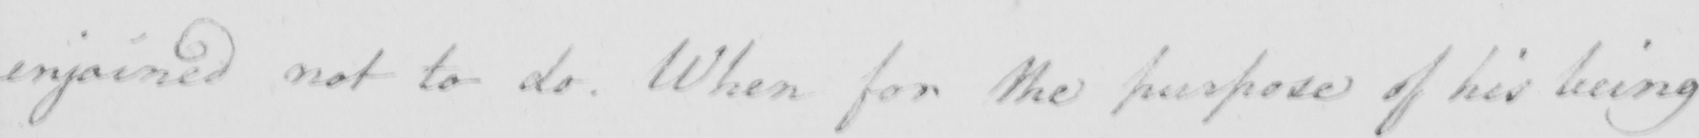Transcribe the text shown in this historical manuscript line. enjoined not to do . When for the purpose of his being 